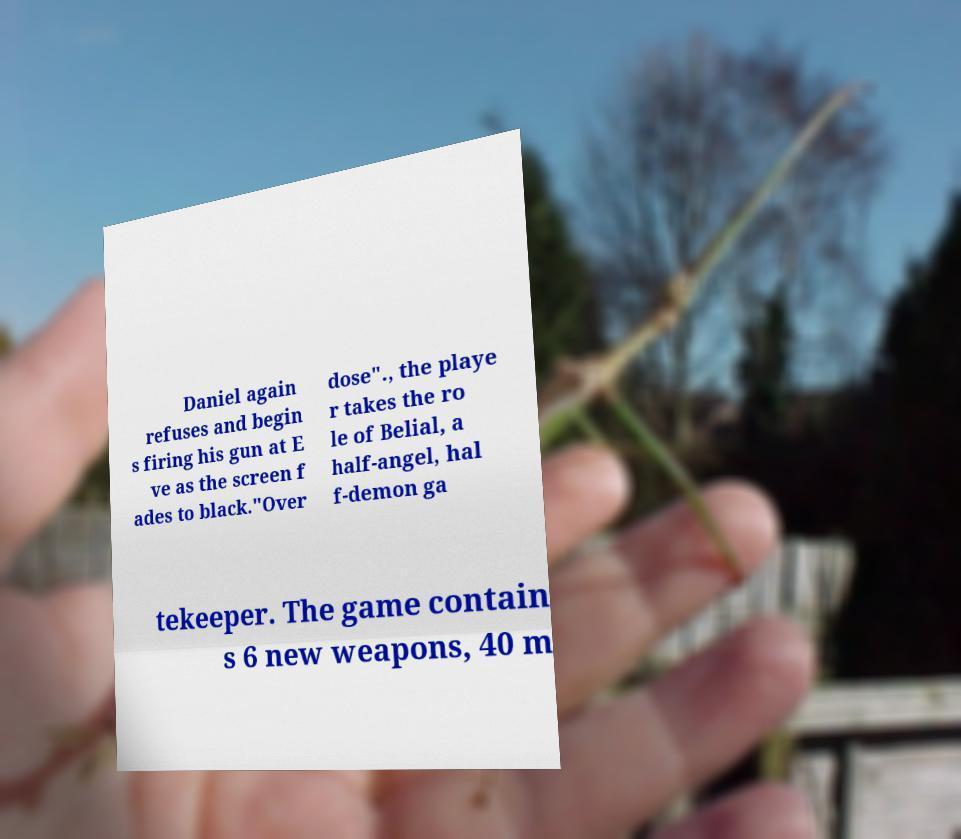Can you accurately transcribe the text from the provided image for me? Daniel again refuses and begin s firing his gun at E ve as the screen f ades to black."Over dose"., the playe r takes the ro le of Belial, a half-angel, hal f-demon ga tekeeper. The game contain s 6 new weapons, 40 m 